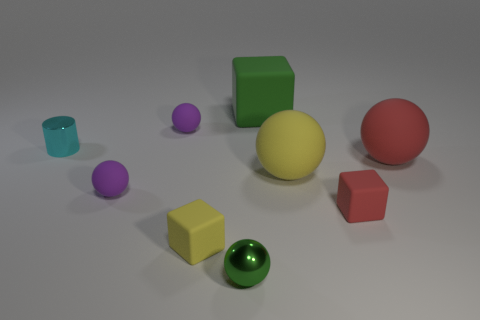What size is the yellow thing that is the same shape as the large green rubber object?
Offer a terse response. Small. Does the green object behind the large red sphere have the same material as the tiny sphere behind the large red thing?
Ensure brevity in your answer.  Yes. Is the number of small red things on the left side of the tiny metallic cylinder less than the number of large red rubber objects?
Your answer should be compact. Yes. Is there anything else that has the same shape as the tiny green shiny object?
Your answer should be compact. Yes. The metallic object that is the same shape as the large red rubber thing is what color?
Give a very brief answer. Green. There is a purple rubber object in front of the cyan metal cylinder; is its size the same as the small cyan metallic cylinder?
Give a very brief answer. Yes. There is a object behind the purple rubber thing that is behind the cyan object; what size is it?
Give a very brief answer. Large. Are the big red sphere and the tiny thing right of the green block made of the same material?
Your response must be concise. Yes. Is the number of small red blocks that are in front of the small green shiny object less than the number of tiny blocks in front of the red matte block?
Provide a succinct answer. Yes. What color is the large block that is the same material as the yellow sphere?
Keep it short and to the point. Green. 